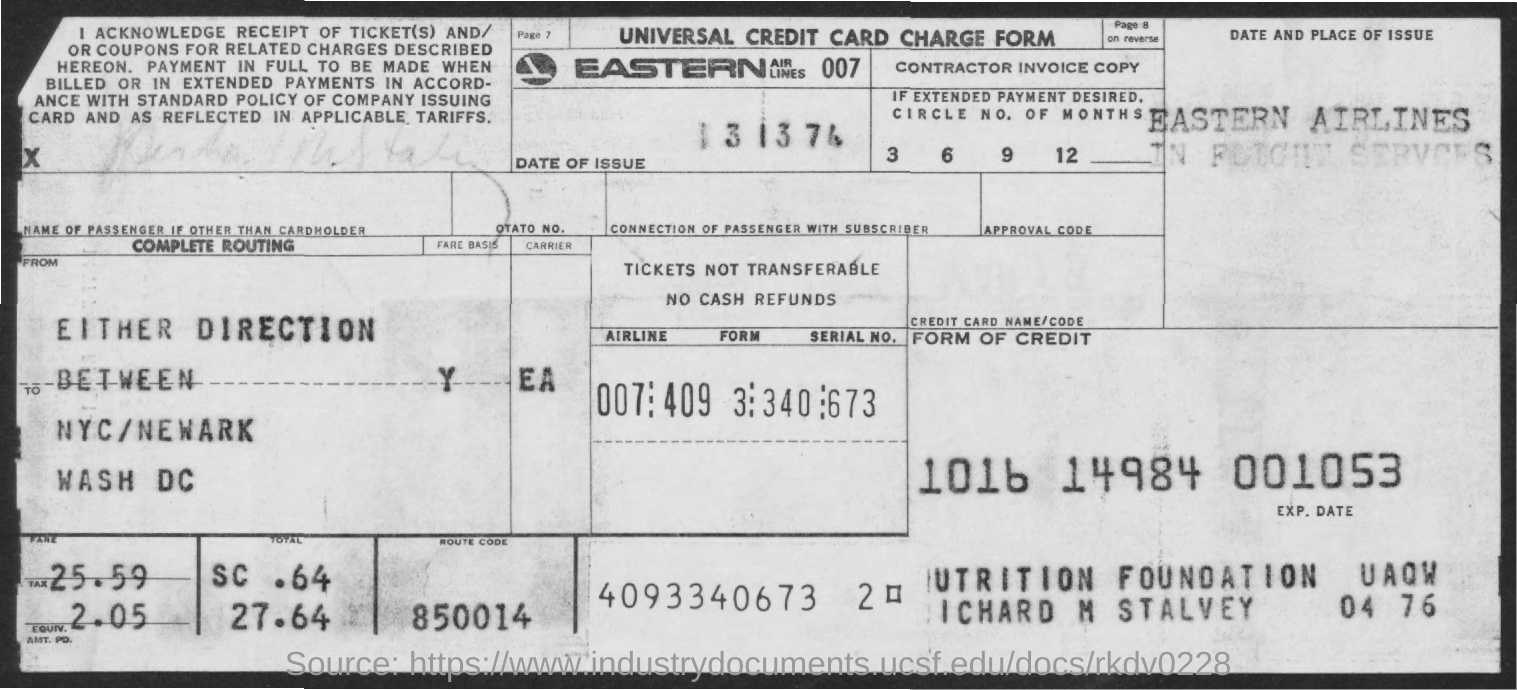Highlight a few significant elements in this photo. The fare amount is 25.59. This document is a Universal Credit card charge form. The tax amount is 2.05. What is the route code for 850014...? Eastern Airlines is mentioned in the conversation. 